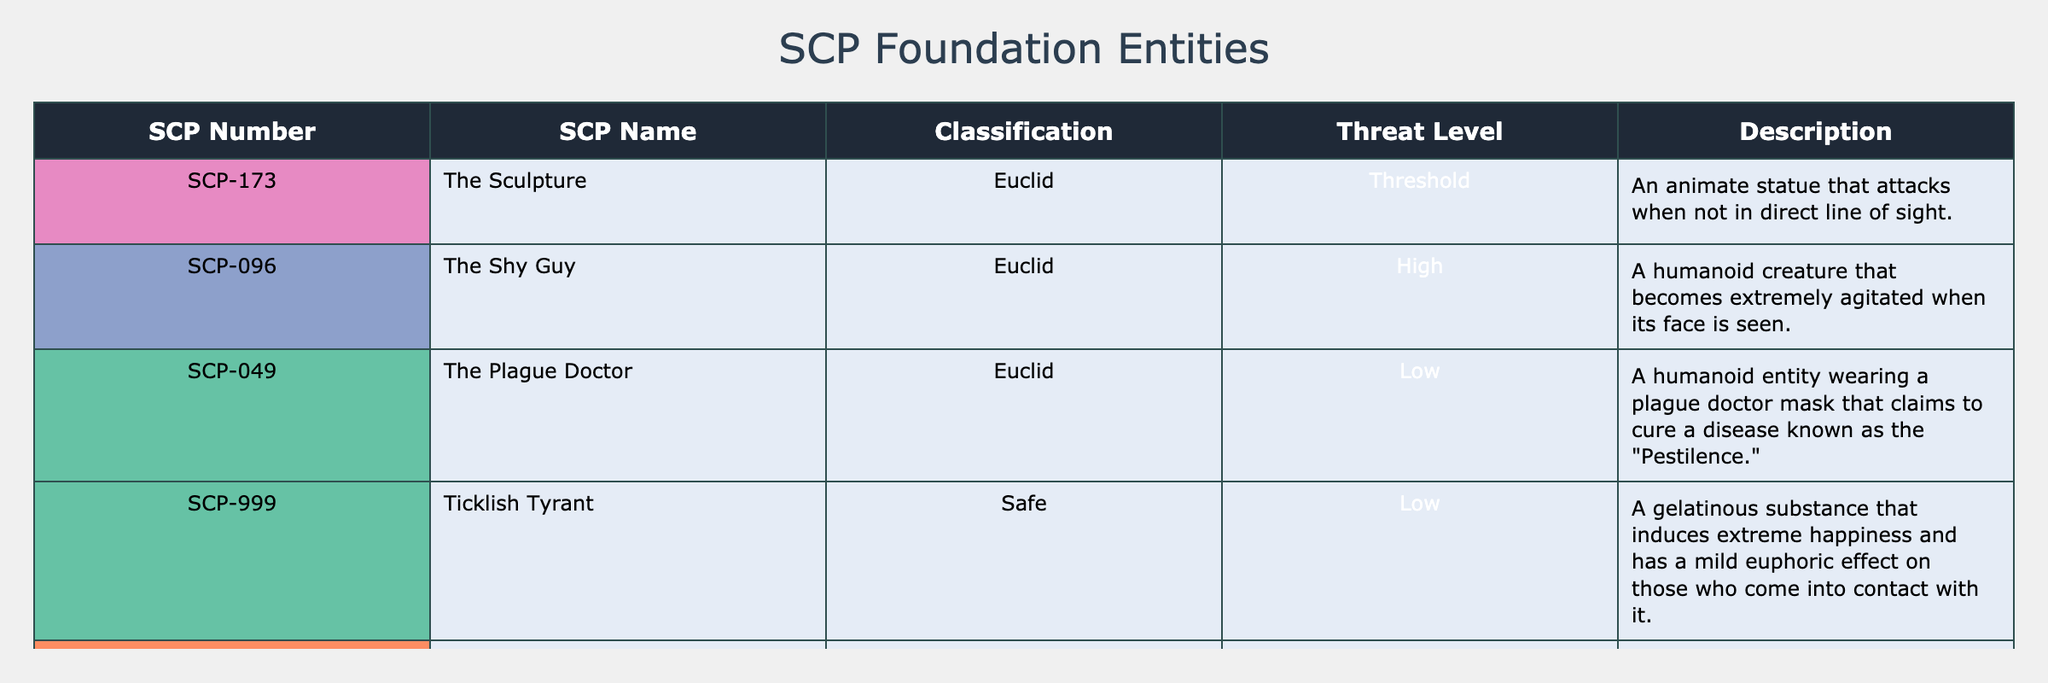What is the SCP number of the humanoid entity that claims to cure a disease? The description mentions a humanoid entity claiming to cure a disease, which refers to SCP-049, the Plague Doctor. Thus, its SCP number is SCP-049.
Answer: SCP-049 How many SCP entities have a threat level classified as Low? By reviewing the threat levels in the table, there are three entities listed as Low: SCP-049 (The Plague Doctor), SCP-999 (Ticklish Tyrant), and SCP-054 (The Water Nymph). Therefore, the count is 3.
Answer: 3 Is SCP-096 classified as Safe? According to the table, SCP-096, also known as The Shy Guy, is classified as Euclid, not Safe. Hence, the statement is false.
Answer: No Which SCP entity has the highest threat level? To determine which entity has the highest threat level, we look at the classifications provided in the table. The only entity categorized under a High threat level is SCP-096 (The Shy Guy). Hence, it has the highest threat level.
Answer: SCP-096 What is the average threat level of the SCP entities classified as Euclid? The SCPs classified as Euclid are SCP-173, SCP-096, SCP-049, SCP-3008, and SCP-054. Their threat levels are Threshold, High, Low, Medium, and Low respectively. To compute the average, we convert the categorical levels into numerical scores: Threshold (1), High (3), Low (2), Medium (2), and Low (2). Summing these gives a total of 10, and dividing by the number of entities (5) results in an average score of 2, which corresponds to Medium (since it lies numerically between Low and High categories).
Answer: Medium Are there more SCP entities with a threat level of Medium or High? Referring to the table, there is one entity with a High threat level (SCP-096) and one with a Medium threat level (SCP-3008). Thus, the count is equal—there are not more of one than the other.
Answer: No 